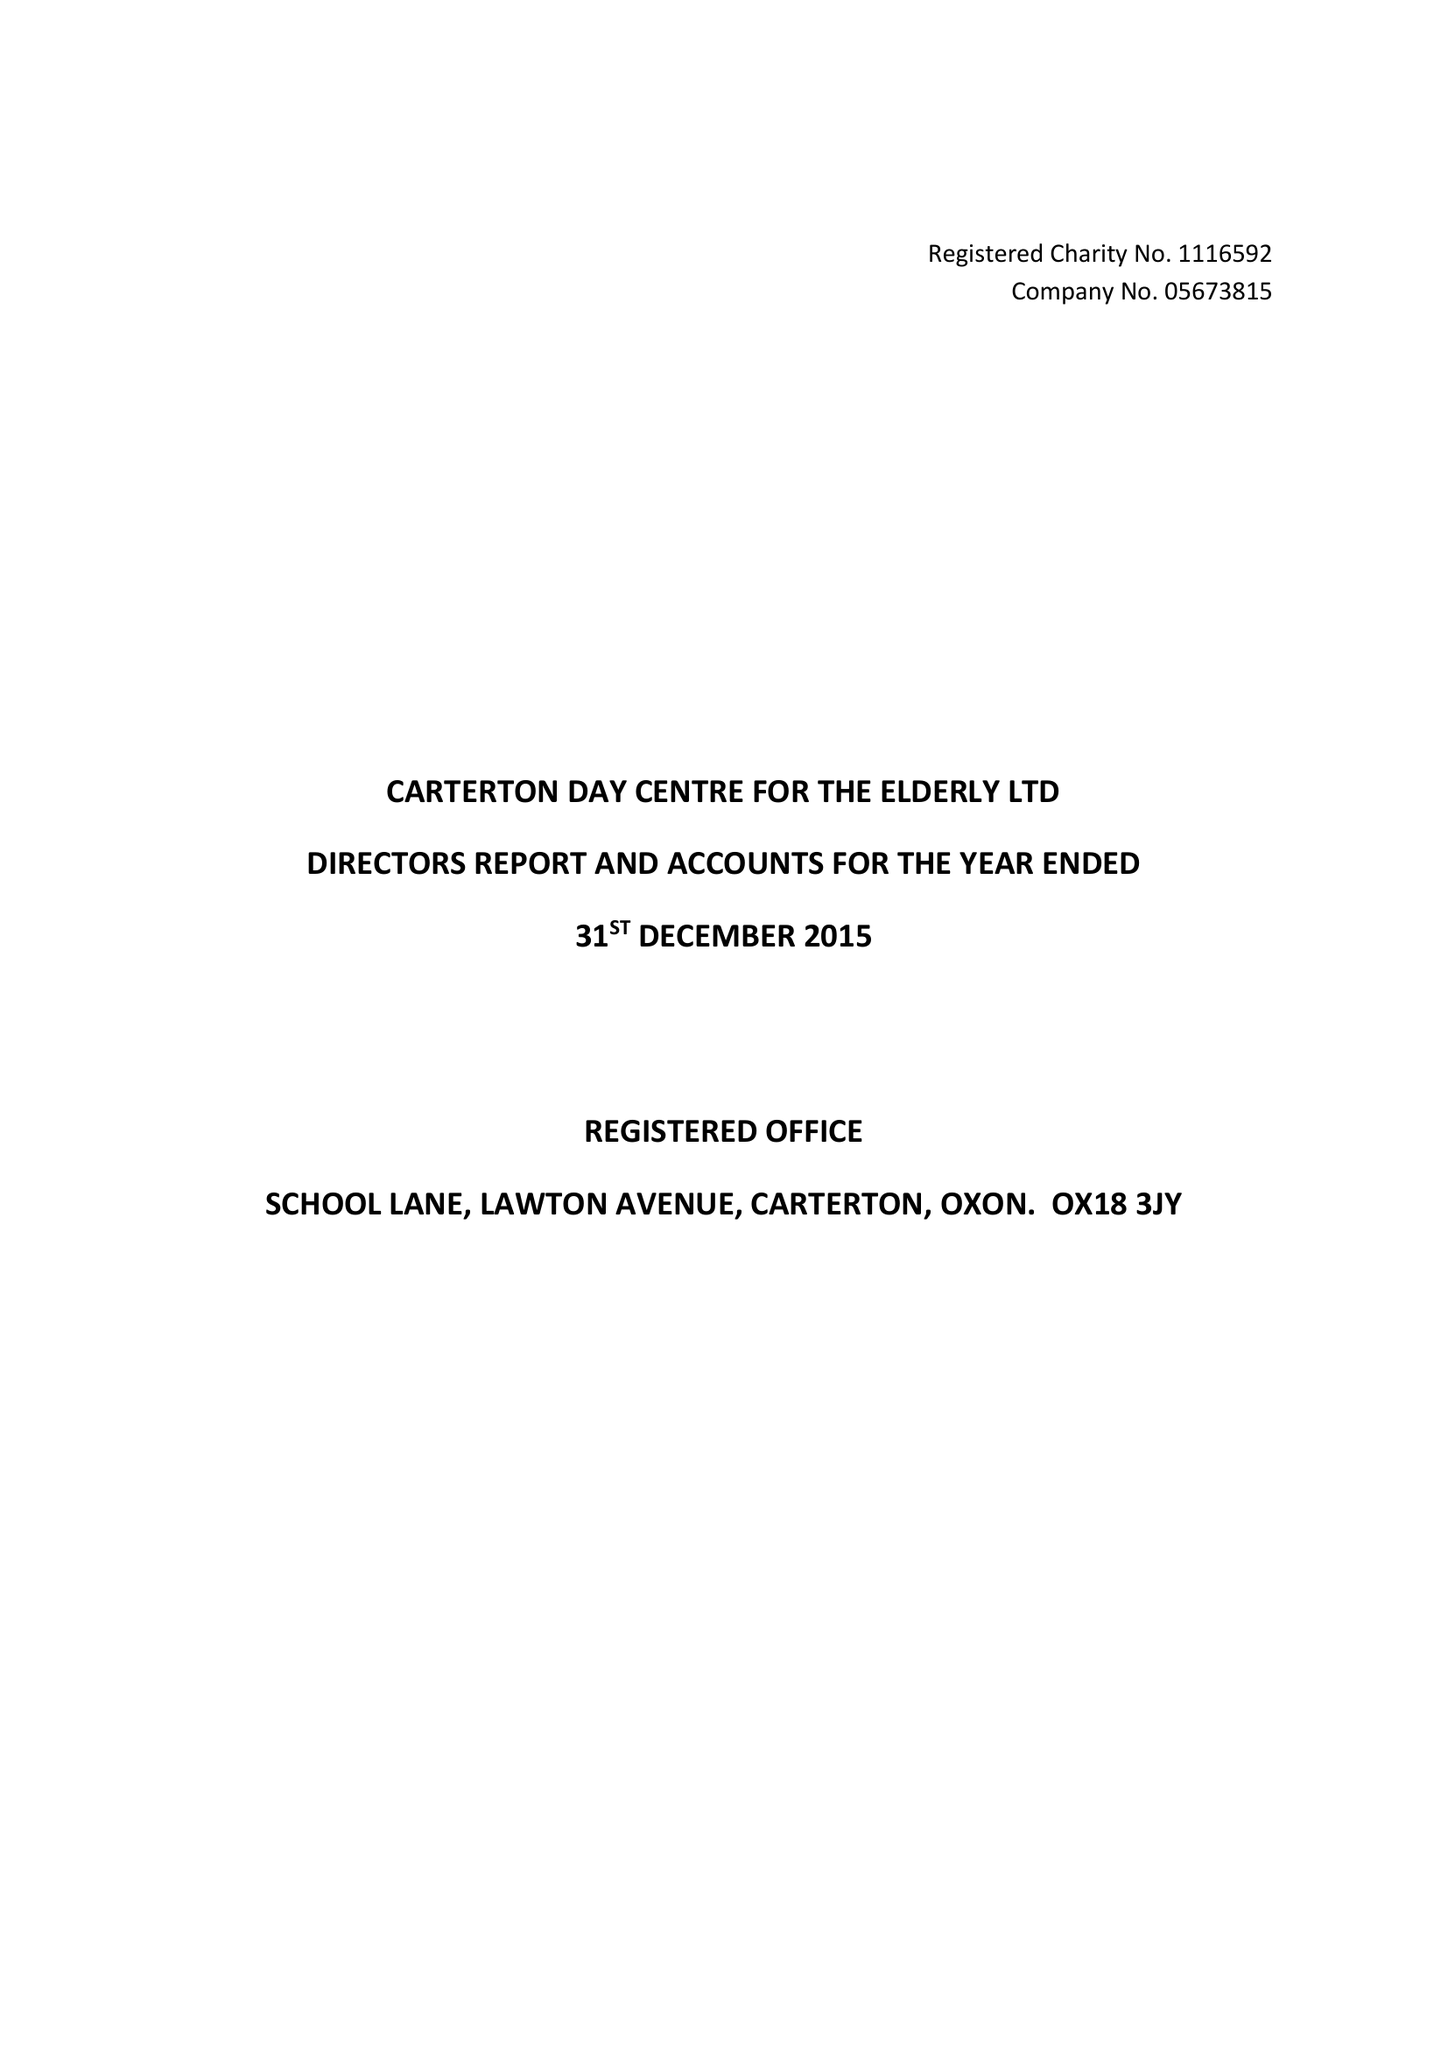What is the value for the address__street_line?
Answer the question using a single word or phrase. LAWTON AVENUE 